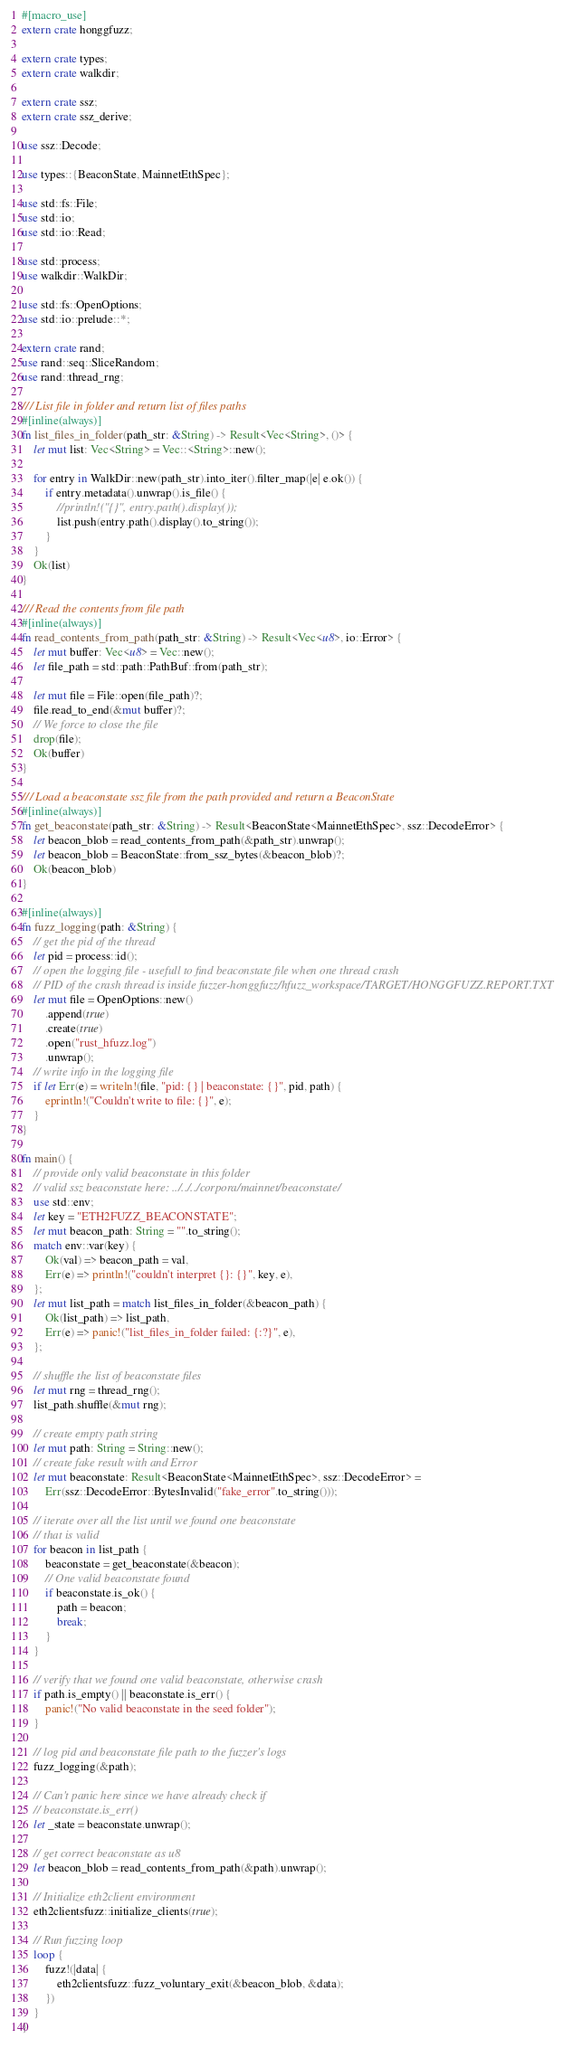<code> <loc_0><loc_0><loc_500><loc_500><_Rust_>#[macro_use]
extern crate honggfuzz;

extern crate types;
extern crate walkdir;

extern crate ssz;
extern crate ssz_derive;

use ssz::Decode;

use types::{BeaconState, MainnetEthSpec};

use std::fs::File;
use std::io;
use std::io::Read;

use std::process;
use walkdir::WalkDir;

use std::fs::OpenOptions;
use std::io::prelude::*;

extern crate rand;
use rand::seq::SliceRandom;
use rand::thread_rng;

/// List file in folder and return list of files paths
#[inline(always)]
fn list_files_in_folder(path_str: &String) -> Result<Vec<String>, ()> {
    let mut list: Vec<String> = Vec::<String>::new();

    for entry in WalkDir::new(path_str).into_iter().filter_map(|e| e.ok()) {
        if entry.metadata().unwrap().is_file() {
            //println!("{}", entry.path().display());
            list.push(entry.path().display().to_string());
        }
    }
    Ok(list)
}

/// Read the contents from file path
#[inline(always)]
fn read_contents_from_path(path_str: &String) -> Result<Vec<u8>, io::Error> {
    let mut buffer: Vec<u8> = Vec::new();
    let file_path = std::path::PathBuf::from(path_str);

    let mut file = File::open(file_path)?;
    file.read_to_end(&mut buffer)?;
    // We force to close the file
    drop(file);
    Ok(buffer)
}

/// Load a beaconstate ssz file from the path provided and return a BeaconState
#[inline(always)]
fn get_beaconstate(path_str: &String) -> Result<BeaconState<MainnetEthSpec>, ssz::DecodeError> {
    let beacon_blob = read_contents_from_path(&path_str).unwrap();
    let beacon_blob = BeaconState::from_ssz_bytes(&beacon_blob)?;
    Ok(beacon_blob)
}

#[inline(always)]
fn fuzz_logging(path: &String) {
    // get the pid of the thread
    let pid = process::id();
    // open the logging file - usefull to find beaconstate file when one thread crash
    // PID of the crash thread is inside fuzzer-honggfuzz/hfuzz_workspace/TARGET/HONGGFUZZ.REPORT.TXT
    let mut file = OpenOptions::new()
        .append(true)
        .create(true)
        .open("rust_hfuzz.log")
        .unwrap();
    // write info in the logging file
    if let Err(e) = writeln!(file, "pid: {} | beaconstate: {}", pid, path) {
        eprintln!("Couldn't write to file: {}", e);
    }
}

fn main() {
    // provide only valid beaconstate in this folder
    // valid ssz beaconstate here: ../../../corpora/mainnet/beaconstate/
    use std::env;
    let key = "ETH2FUZZ_BEACONSTATE";
    let mut beacon_path: String = "".to_string();
    match env::var(key) {
        Ok(val) => beacon_path = val,
        Err(e) => println!("couldn't interpret {}: {}", key, e),
    };
    let mut list_path = match list_files_in_folder(&beacon_path) {
        Ok(list_path) => list_path,
        Err(e) => panic!("list_files_in_folder failed: {:?}", e),
    };

    // shuffle the list of beaconstate files
    let mut rng = thread_rng();
    list_path.shuffle(&mut rng);

    // create empty path string
    let mut path: String = String::new();
    // create fake result with and Error
    let mut beaconstate: Result<BeaconState<MainnetEthSpec>, ssz::DecodeError> =
        Err(ssz::DecodeError::BytesInvalid("fake_error".to_string()));

    // iterate over all the list until we found one beaconstate
    // that is valid
    for beacon in list_path {
        beaconstate = get_beaconstate(&beacon);
        // One valid beaconstate found
        if beaconstate.is_ok() {
            path = beacon;
            break;
        }
    }

    // verify that we found one valid beaconstate, otherwise crash
    if path.is_empty() || beaconstate.is_err() {
        panic!("No valid beaconstate in the seed folder");
    }

    // log pid and beaconstate file path to the fuzzer's logs
    fuzz_logging(&path);

    // Can't panic here since we have already check if
    // beaconstate.is_err()
    let _state = beaconstate.unwrap();

    // get correct beaconstate as u8
    let beacon_blob = read_contents_from_path(&path).unwrap();

    // Initialize eth2client environment
    eth2clientsfuzz::initialize_clients(true);

    // Run fuzzing loop
    loop {
        fuzz!(|data| {
            eth2clientsfuzz::fuzz_voluntary_exit(&beacon_blob, &data);
        })
    }
}
</code> 